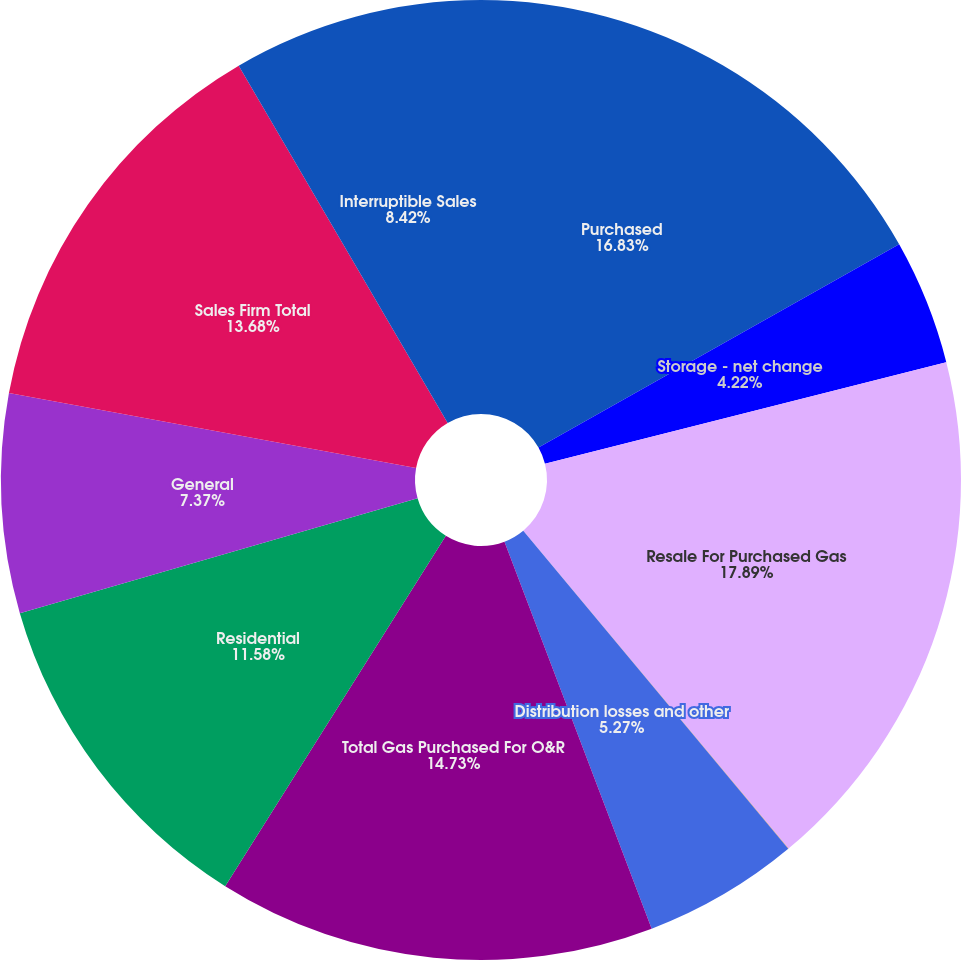Convert chart. <chart><loc_0><loc_0><loc_500><loc_500><pie_chart><fcel>Purchased<fcel>Storage - net change<fcel>Resale For Purchased Gas<fcel>Less Gas used by the company<fcel>Distribution losses and other<fcel>Total Gas Purchased For O&R<fcel>Residential<fcel>General<fcel>Sales Firm Total<fcel>Interruptible Sales<nl><fcel>16.83%<fcel>4.22%<fcel>17.88%<fcel>0.01%<fcel>5.27%<fcel>14.73%<fcel>11.58%<fcel>7.37%<fcel>13.68%<fcel>8.42%<nl></chart> 